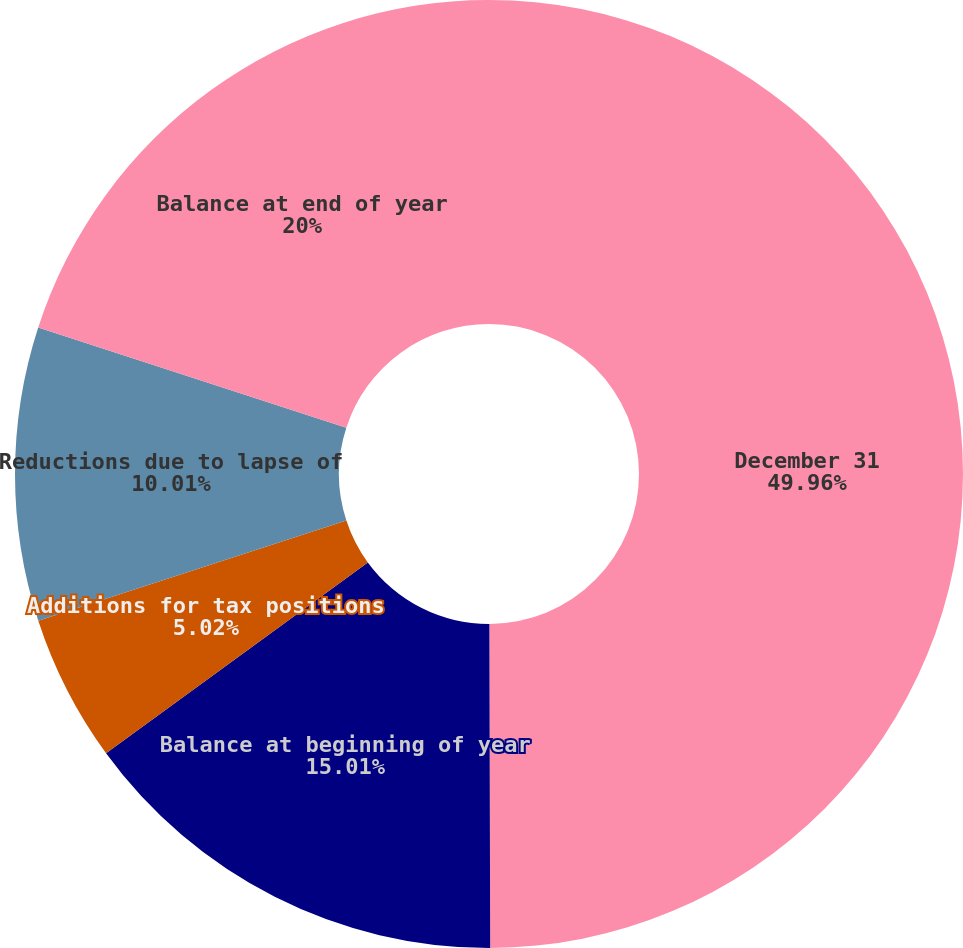Convert chart to OTSL. <chart><loc_0><loc_0><loc_500><loc_500><pie_chart><fcel>December 31<fcel>Balance at beginning of year<fcel>Additions for tax positions<fcel>Reductions due to lapse of<fcel>Balance at end of year<nl><fcel>49.96%<fcel>15.01%<fcel>5.02%<fcel>10.01%<fcel>20.0%<nl></chart> 